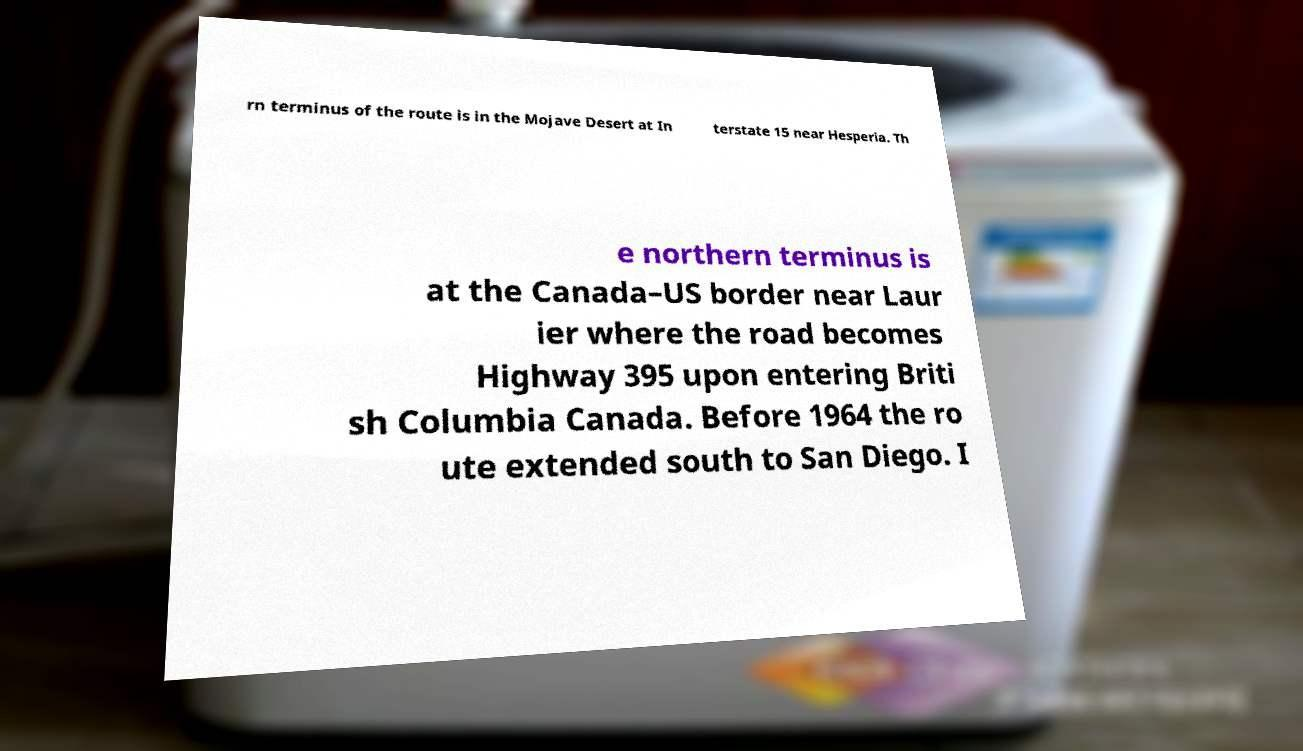Can you read and provide the text displayed in the image?This photo seems to have some interesting text. Can you extract and type it out for me? rn terminus of the route is in the Mojave Desert at In terstate 15 near Hesperia. Th e northern terminus is at the Canada–US border near Laur ier where the road becomes Highway 395 upon entering Briti sh Columbia Canada. Before 1964 the ro ute extended south to San Diego. I 